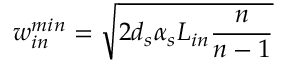Convert formula to latex. <formula><loc_0><loc_0><loc_500><loc_500>w _ { i n } ^ { \min } = \sqrt { 2 d _ { s } \alpha _ { s } L _ { i n } \frac { n } { n - 1 } }</formula> 